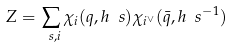Convert formula to latex. <formula><loc_0><loc_0><loc_500><loc_500>Z = \sum _ { \ s , i } \chi _ { i } ( q , h _ { \ } s ) \chi _ { i ^ { \vee } } ( \bar { q } , h _ { \ } s ^ { - 1 } )</formula> 